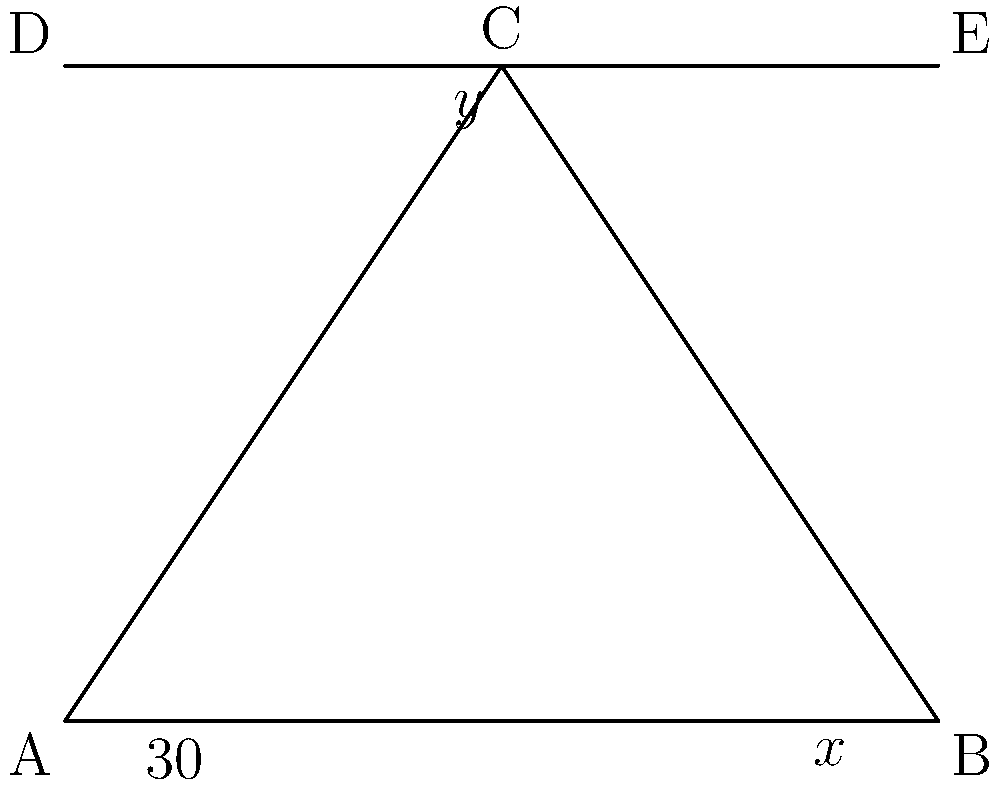At an archaeological dig site, two intersecting trenches form a triangle ABC and a line DE. If angle BAC is 30°, and angles x and y are equal, what is the value of x? Let's solve this step-by-step:

1) In triangle ABC, we know that the sum of all angles must be 180°:
   $$ \angle BAC + \angle ABC + \angle BCA = 180° $$

2) We're given that $\angle BAC = 30°$, so:
   $$ 30° + \angle ABC + \angle BCA = 180° $$

3) Line DE is parallel to AB, creating alternate angles. This means:
   $$ \angle BCA = y° $$

4) We're told that $x = y$, so we can substitute:
   $$ 30° + x° + x° = 180° $$

5) Simplify:
   $$ 30° + 2x° = 180° $$

6) Subtract 30° from both sides:
   $$ 2x° = 150° $$

7) Divide both sides by 2:
   $$ x° = 75° $$

Therefore, the value of x is 75°.
Answer: 75° 